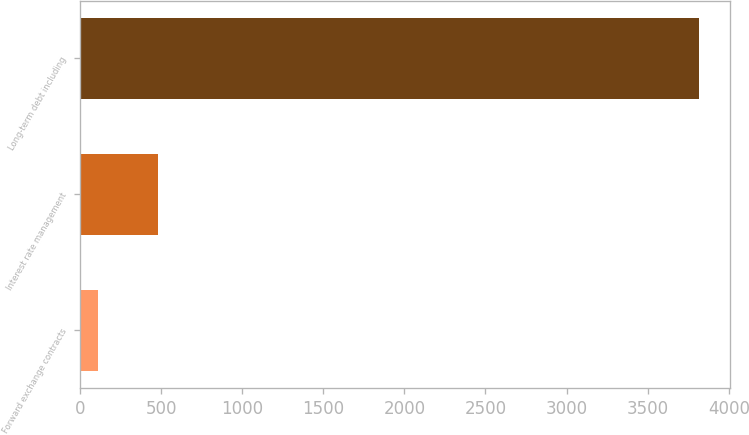<chart> <loc_0><loc_0><loc_500><loc_500><bar_chart><fcel>Forward exchange contracts<fcel>Interest rate management<fcel>Long-term debt including<nl><fcel>109.9<fcel>480.79<fcel>3818.8<nl></chart> 